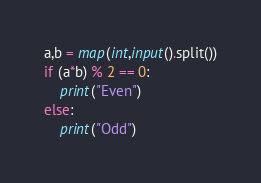Convert code to text. <code><loc_0><loc_0><loc_500><loc_500><_Python_>a,b = map(int,input().split())
if (a*b) % 2 == 0:
    print("Even")
else:
    print("Odd")</code> 